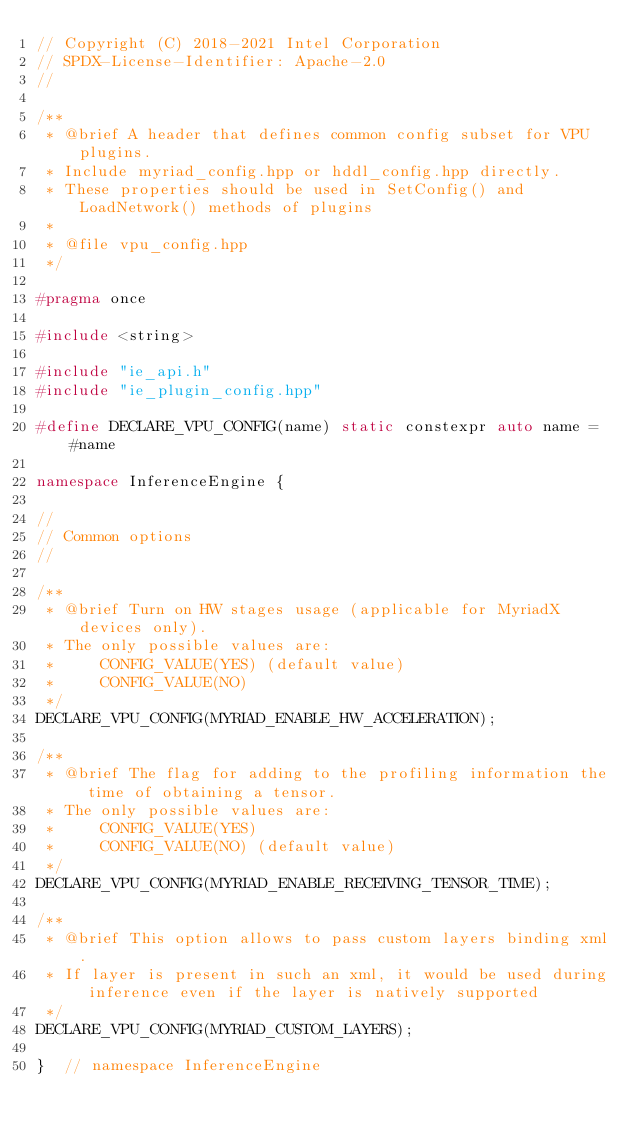<code> <loc_0><loc_0><loc_500><loc_500><_C++_>// Copyright (C) 2018-2021 Intel Corporation
// SPDX-License-Identifier: Apache-2.0
//

/**
 * @brief A header that defines common config subset for VPU plugins.
 * Include myriad_config.hpp or hddl_config.hpp directly.
 * These properties should be used in SetConfig() and LoadNetwork() methods of plugins
 *
 * @file vpu_config.hpp
 */

#pragma once

#include <string>

#include "ie_api.h"
#include "ie_plugin_config.hpp"

#define DECLARE_VPU_CONFIG(name) static constexpr auto name = #name

namespace InferenceEngine {

//
// Common options
//

/**
 * @brief Turn on HW stages usage (applicable for MyriadX devices only).
 * The only possible values are:
 *     CONFIG_VALUE(YES) (default value)
 *     CONFIG_VALUE(NO)
 */
DECLARE_VPU_CONFIG(MYRIAD_ENABLE_HW_ACCELERATION);

/**
 * @brief The flag for adding to the profiling information the time of obtaining a tensor.
 * The only possible values are:
 *     CONFIG_VALUE(YES)
 *     CONFIG_VALUE(NO) (default value)
 */
DECLARE_VPU_CONFIG(MYRIAD_ENABLE_RECEIVING_TENSOR_TIME);

/**
 * @brief This option allows to pass custom layers binding xml.
 * If layer is present in such an xml, it would be used during inference even if the layer is natively supported
 */
DECLARE_VPU_CONFIG(MYRIAD_CUSTOM_LAYERS);

}  // namespace InferenceEngine
</code> 